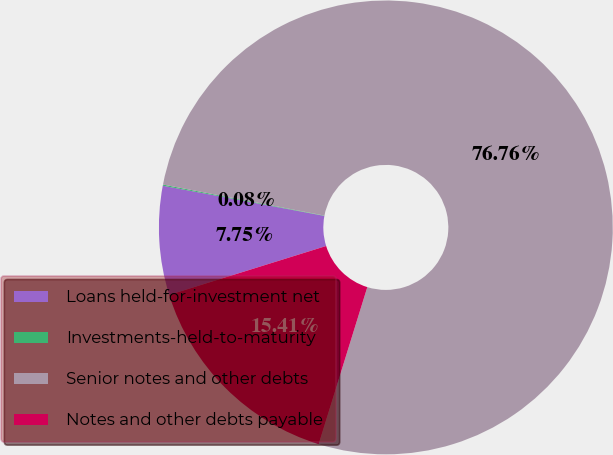Convert chart. <chart><loc_0><loc_0><loc_500><loc_500><pie_chart><fcel>Loans held-for-investment net<fcel>Investments-held-to-maturity<fcel>Senior notes and other debts<fcel>Notes and other debts payable<nl><fcel>7.75%<fcel>0.08%<fcel>76.76%<fcel>15.41%<nl></chart> 